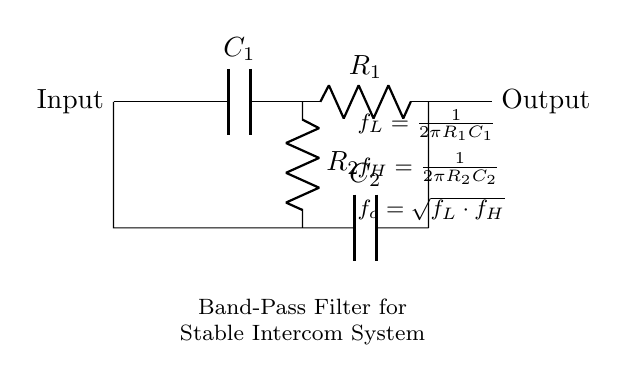What components are in the circuit? The diagram shows two resistors (R1 and R2) and two capacitors (C1 and C2) connected in a specific arrangement.
Answer: Resistors and capacitors What type of filter is represented in the circuit? The circuit diagram is labeled as a "Band-Pass Filter," indicating its function to allow frequencies within a certain range to pass while attenuating others.
Answer: Band-Pass Filter What is the formula for the lower cutoff frequency? The formula for the lower cutoff frequency \( f_L \) is given as \( f_L = \frac{1}{2\pi R_1 C_1} \), which shows how it depends on resistors and capacitors.
Answer: \( f_L = \frac{1}{2\pi R_1 C_1} \) What is the output of this circuit? The output is indicated to be the signal that passes through the circuit after filtering, connected directly after the component arrangement.
Answer: Output signal How does the arrangement of components affect frequency response? The combination of resistors and capacitors determines the cutoff frequencies \( f_L \) and \( f_H \), establishing the range of frequencies that the filter will allow to pass, which defines its behavior as a band-pass filter.
Answer: Defines frequency response What do f_H and f_L represent in the circuit? The symbols \( f_H \) and \( f_L \) denote the high and low cutoff frequencies, respectively, establishing the range of frequencies that the filter will permit and is critical in understanding filter characteristics.
Answer: High and low cutoff frequencies 